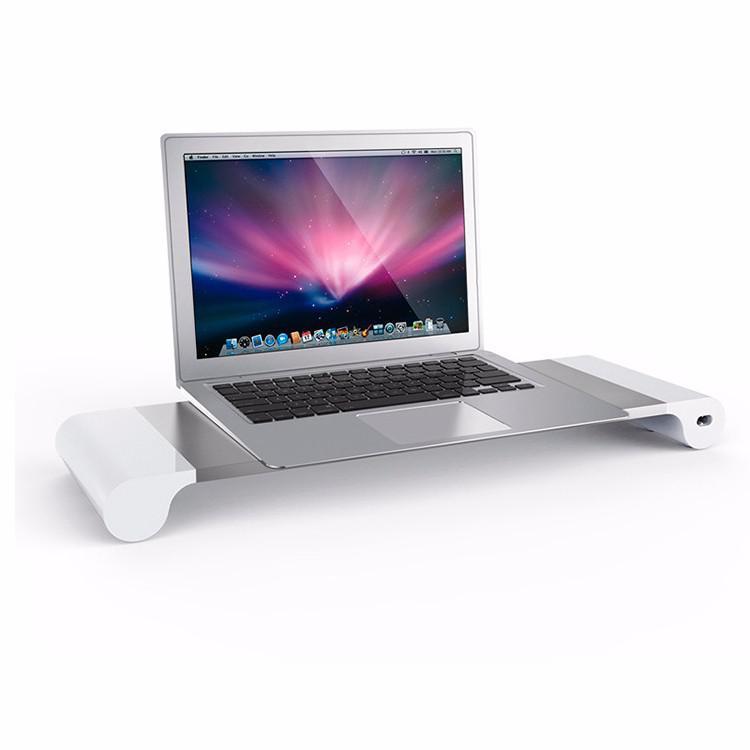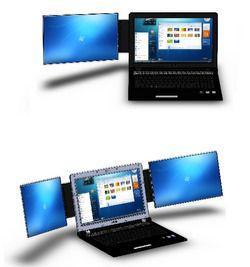The first image is the image on the left, the second image is the image on the right. Analyze the images presented: Is the assertion "There is exactly one laptop in the left image." valid? Answer yes or no. Yes. The first image is the image on the left, the second image is the image on the right. Considering the images on both sides, is "An image includes side-by-side monitors with blue curving lines on the screen, and a smaller laptop." valid? Answer yes or no. No. 